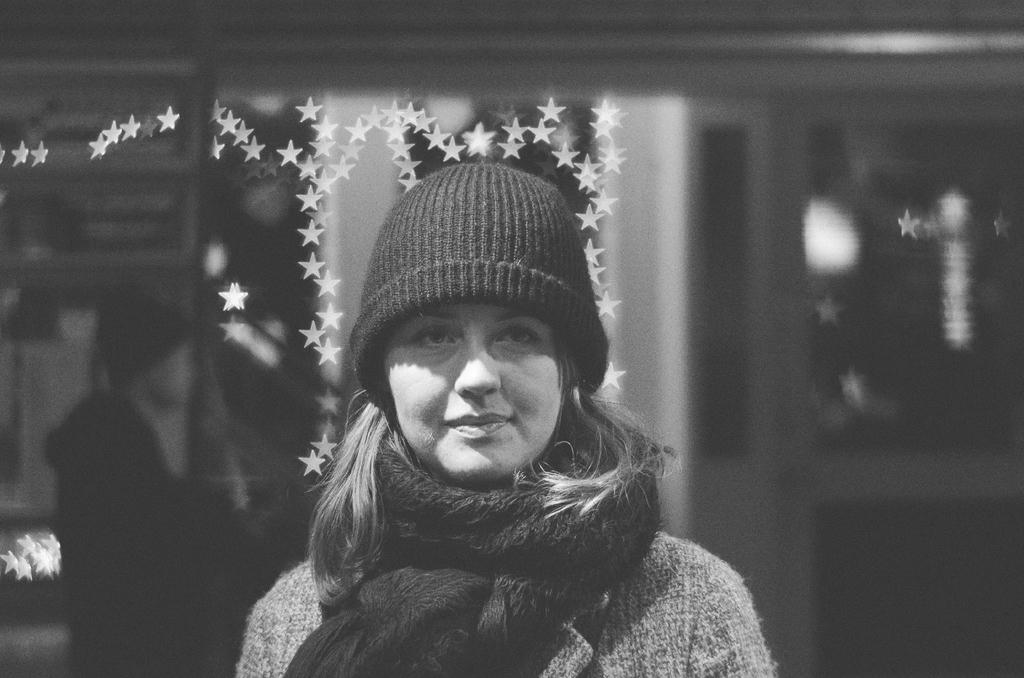What is the main subject of the image? The main subject of the image is a lady person. Can you describe the lady person's clothing? The lady person is wearing a grey color sweater and a black color cap. She is also wearing a shrug. What type of songs can be heard in the background of the image? There is no information about songs or any audio in the image, so it cannot be determined from the image. 